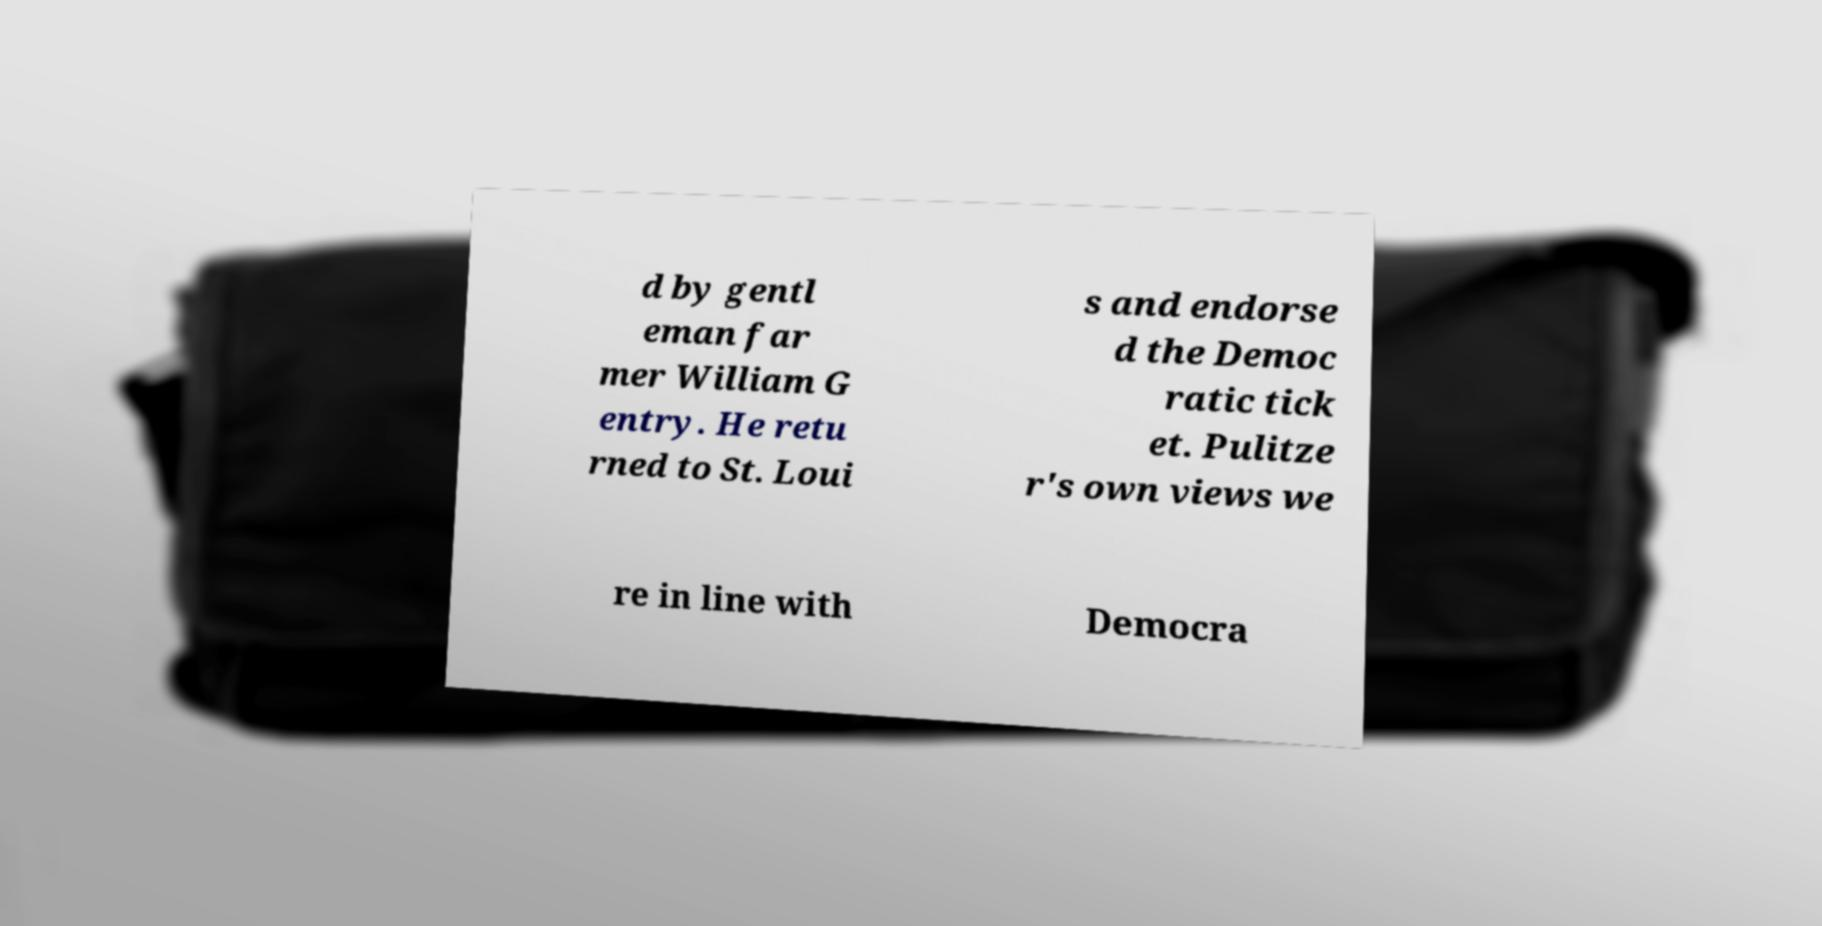Can you accurately transcribe the text from the provided image for me? d by gentl eman far mer William G entry. He retu rned to St. Loui s and endorse d the Democ ratic tick et. Pulitze r's own views we re in line with Democra 